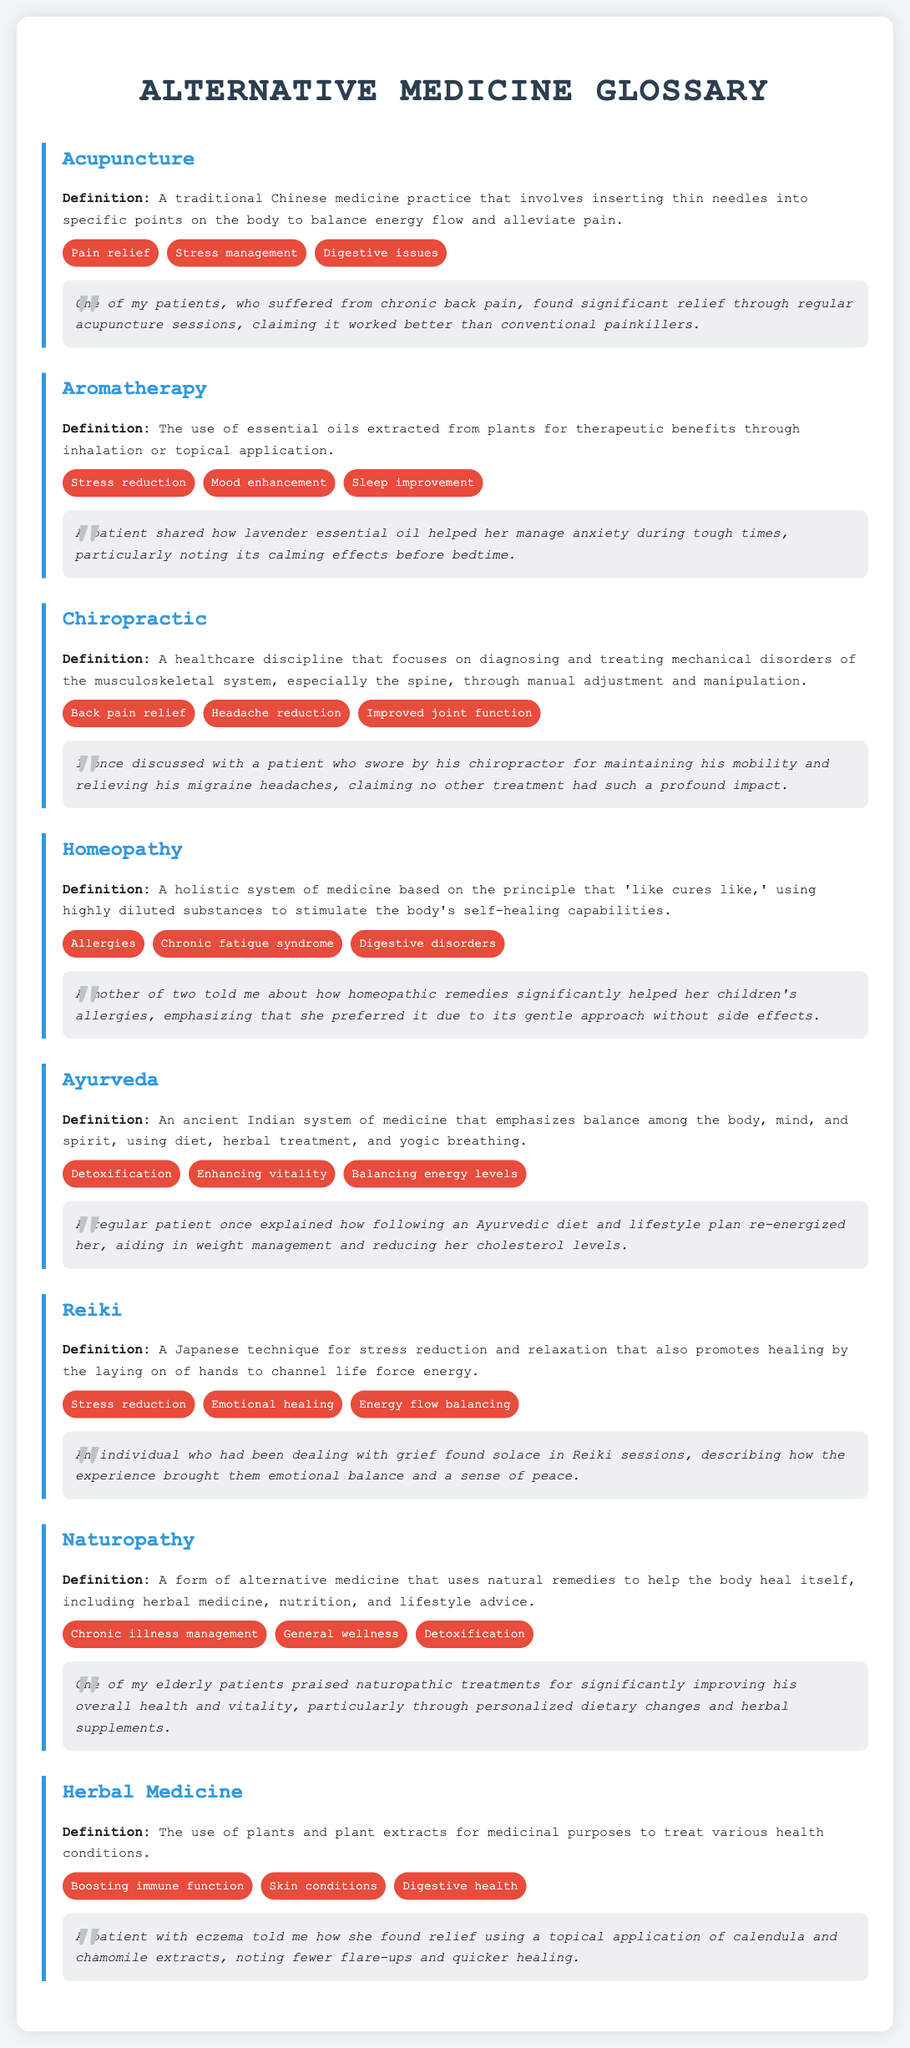What is acupuncture? Acupuncture is defined as a traditional Chinese medicine practice that involves inserting thin needles into specific points on the body to balance energy flow and alleviate pain.
Answer: A traditional Chinese medicine practice What is the common use of herbal medicine related to skin conditions? Herbal medicine is commonly used to treat various health conditions, including boosting immune function, skin conditions, and digestive health.
Answer: Skin conditions Which alternative medicine practice emphasizes balance among body, mind, and spirit? Ayurveda is an ancient Indian system of medicine that emphasizes balance among the body, mind, and spirit.
Answer: Ayurveda How does Reiki promote healing? Reiki promotes healing by the laying on of hands to channel life force energy for stress reduction and relaxation.
Answer: By the laying on of hands What anecdote did a patient share about lavender essential oil? A patient shared how lavender essential oil helped her manage anxiety during tough times, particularly noting its calming effects before bedtime.
Answer: Helped manage anxiety What are the common uses of chiropractic? Common uses of chiropractic include back pain relief, headache reduction, and improved joint function.
Answer: Back pain relief, headache reduction, improved joint function How is homeopathy described in the document? Homeopathy is described as a holistic system of medicine based on the principle that 'like cures like,' using highly diluted substances.
Answer: A holistic system of medicine Which practice is noted for aiding in chronic fatigue syndrome? Homeopathy is noted for its common use in aiding chronic fatigue syndrome among other conditions.
Answer: Homeopathy What does a patient claim about his chiropractor? The patient claimed no other treatment had such a profound impact as his chiropractor for maintaining mobility and relieving migraines.
Answer: No other treatment had such a profound impact 